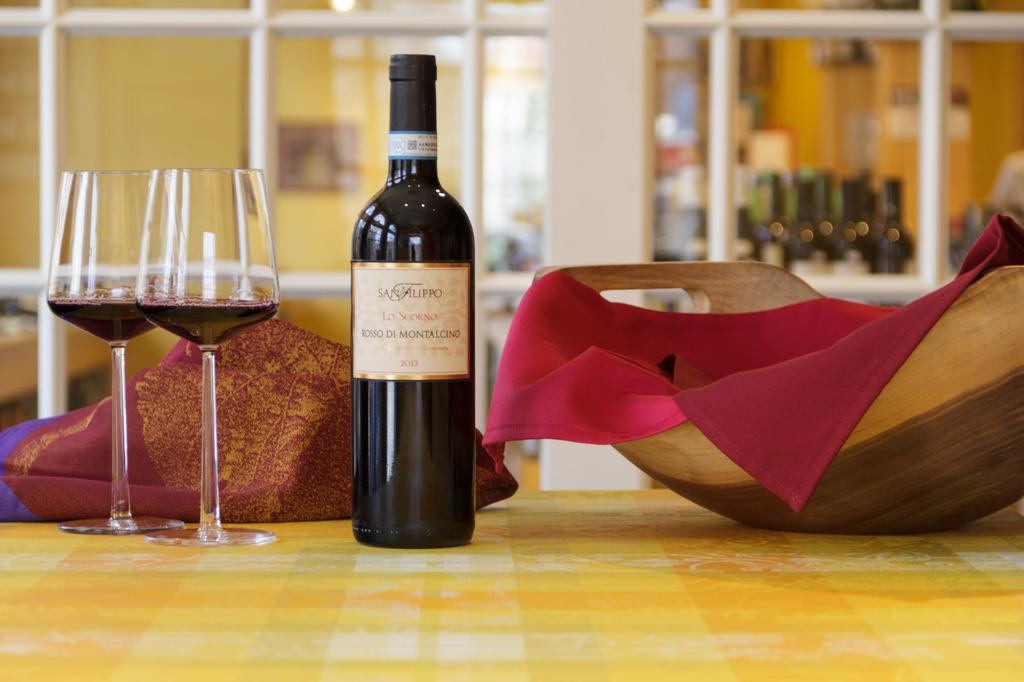<image>
Offer a succinct explanation of the picture presented. Wine bottle from the year 2013 next to two glass cups. 